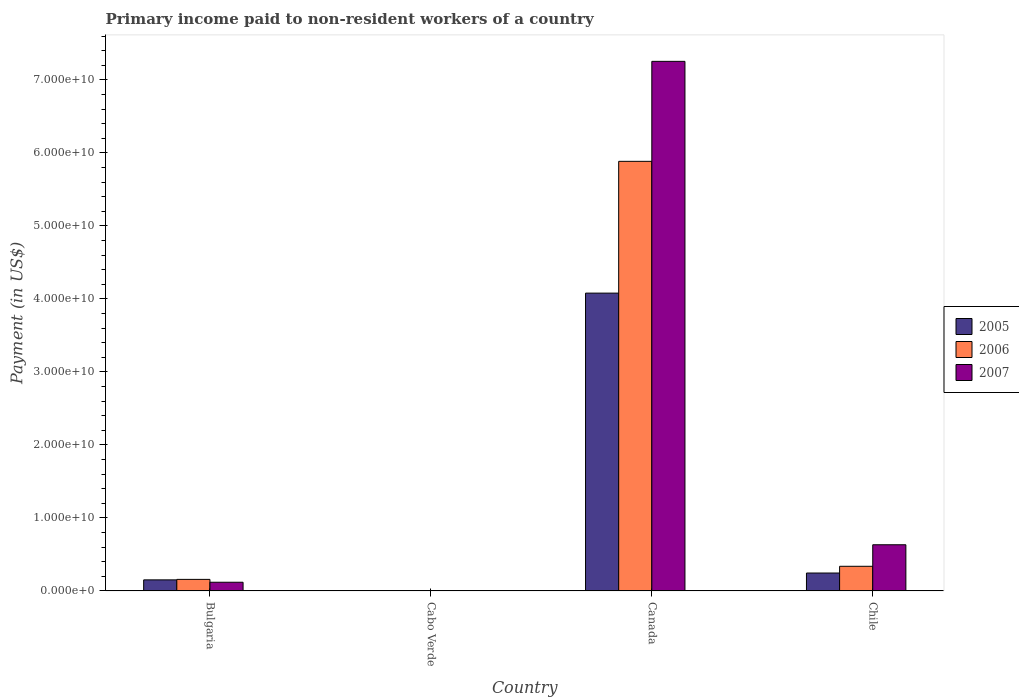How many different coloured bars are there?
Your answer should be compact. 3. How many groups of bars are there?
Provide a short and direct response. 4. Are the number of bars per tick equal to the number of legend labels?
Give a very brief answer. Yes. Are the number of bars on each tick of the X-axis equal?
Offer a terse response. Yes. What is the label of the 3rd group of bars from the left?
Offer a very short reply. Canada. What is the amount paid to workers in 2006 in Canada?
Provide a short and direct response. 5.89e+1. Across all countries, what is the maximum amount paid to workers in 2006?
Provide a short and direct response. 5.89e+1. Across all countries, what is the minimum amount paid to workers in 2005?
Offer a very short reply. 1.92e+07. In which country was the amount paid to workers in 2007 maximum?
Your answer should be compact. Canada. In which country was the amount paid to workers in 2006 minimum?
Offer a terse response. Cabo Verde. What is the total amount paid to workers in 2007 in the graph?
Ensure brevity in your answer.  8.01e+1. What is the difference between the amount paid to workers in 2005 in Cabo Verde and that in Canada?
Offer a terse response. -4.08e+1. What is the difference between the amount paid to workers in 2005 in Cabo Verde and the amount paid to workers in 2006 in Bulgaria?
Your answer should be compact. -1.56e+09. What is the average amount paid to workers in 2006 per country?
Give a very brief answer. 1.60e+1. What is the difference between the amount paid to workers of/in 2007 and amount paid to workers of/in 2005 in Bulgaria?
Your answer should be compact. -3.26e+08. What is the ratio of the amount paid to workers in 2005 in Bulgaria to that in Cabo Verde?
Your response must be concise. 78.83. Is the difference between the amount paid to workers in 2007 in Cabo Verde and Chile greater than the difference between the amount paid to workers in 2005 in Cabo Verde and Chile?
Make the answer very short. No. What is the difference between the highest and the second highest amount paid to workers in 2006?
Offer a terse response. -5.55e+1. What is the difference between the highest and the lowest amount paid to workers in 2006?
Keep it short and to the point. 5.88e+1. What does the 3rd bar from the right in Canada represents?
Provide a short and direct response. 2005. How many countries are there in the graph?
Provide a short and direct response. 4. What is the difference between two consecutive major ticks on the Y-axis?
Your answer should be compact. 1.00e+1. Does the graph contain any zero values?
Your answer should be very brief. No. What is the title of the graph?
Provide a short and direct response. Primary income paid to non-resident workers of a country. What is the label or title of the X-axis?
Give a very brief answer. Country. What is the label or title of the Y-axis?
Provide a succinct answer. Payment (in US$). What is the Payment (in US$) of 2005 in Bulgaria?
Make the answer very short. 1.52e+09. What is the Payment (in US$) of 2006 in Bulgaria?
Provide a succinct answer. 1.58e+09. What is the Payment (in US$) of 2007 in Bulgaria?
Give a very brief answer. 1.19e+09. What is the Payment (in US$) in 2005 in Cabo Verde?
Provide a succinct answer. 1.92e+07. What is the Payment (in US$) in 2006 in Cabo Verde?
Offer a very short reply. 1.91e+07. What is the Payment (in US$) in 2007 in Cabo Verde?
Your answer should be compact. 2.67e+07. What is the Payment (in US$) in 2005 in Canada?
Offer a terse response. 4.08e+1. What is the Payment (in US$) in 2006 in Canada?
Make the answer very short. 5.89e+1. What is the Payment (in US$) of 2007 in Canada?
Provide a succinct answer. 7.26e+1. What is the Payment (in US$) in 2005 in Chile?
Offer a very short reply. 2.45e+09. What is the Payment (in US$) in 2006 in Chile?
Your answer should be compact. 3.37e+09. What is the Payment (in US$) in 2007 in Chile?
Make the answer very short. 6.32e+09. Across all countries, what is the maximum Payment (in US$) in 2005?
Make the answer very short. 4.08e+1. Across all countries, what is the maximum Payment (in US$) in 2006?
Your answer should be very brief. 5.89e+1. Across all countries, what is the maximum Payment (in US$) in 2007?
Offer a very short reply. 7.26e+1. Across all countries, what is the minimum Payment (in US$) in 2005?
Offer a very short reply. 1.92e+07. Across all countries, what is the minimum Payment (in US$) in 2006?
Offer a very short reply. 1.91e+07. Across all countries, what is the minimum Payment (in US$) in 2007?
Provide a succinct answer. 2.67e+07. What is the total Payment (in US$) in 2005 in the graph?
Ensure brevity in your answer.  4.48e+1. What is the total Payment (in US$) in 2006 in the graph?
Give a very brief answer. 6.38e+1. What is the total Payment (in US$) in 2007 in the graph?
Your answer should be very brief. 8.01e+1. What is the difference between the Payment (in US$) in 2005 in Bulgaria and that in Cabo Verde?
Ensure brevity in your answer.  1.50e+09. What is the difference between the Payment (in US$) in 2006 in Bulgaria and that in Cabo Verde?
Offer a terse response. 1.56e+09. What is the difference between the Payment (in US$) in 2007 in Bulgaria and that in Cabo Verde?
Make the answer very short. 1.16e+09. What is the difference between the Payment (in US$) of 2005 in Bulgaria and that in Canada?
Keep it short and to the point. -3.93e+1. What is the difference between the Payment (in US$) in 2006 in Bulgaria and that in Canada?
Your answer should be very brief. -5.73e+1. What is the difference between the Payment (in US$) in 2007 in Bulgaria and that in Canada?
Give a very brief answer. -7.14e+1. What is the difference between the Payment (in US$) in 2005 in Bulgaria and that in Chile?
Keep it short and to the point. -9.36e+08. What is the difference between the Payment (in US$) of 2006 in Bulgaria and that in Chile?
Give a very brief answer. -1.79e+09. What is the difference between the Payment (in US$) in 2007 in Bulgaria and that in Chile?
Keep it short and to the point. -5.14e+09. What is the difference between the Payment (in US$) of 2005 in Cabo Verde and that in Canada?
Provide a succinct answer. -4.08e+1. What is the difference between the Payment (in US$) in 2006 in Cabo Verde and that in Canada?
Keep it short and to the point. -5.88e+1. What is the difference between the Payment (in US$) in 2007 in Cabo Verde and that in Canada?
Offer a very short reply. -7.25e+1. What is the difference between the Payment (in US$) in 2005 in Cabo Verde and that in Chile?
Make the answer very short. -2.43e+09. What is the difference between the Payment (in US$) in 2006 in Cabo Verde and that in Chile?
Offer a very short reply. -3.36e+09. What is the difference between the Payment (in US$) in 2007 in Cabo Verde and that in Chile?
Provide a succinct answer. -6.30e+09. What is the difference between the Payment (in US$) of 2005 in Canada and that in Chile?
Provide a succinct answer. 3.83e+1. What is the difference between the Payment (in US$) in 2006 in Canada and that in Chile?
Provide a succinct answer. 5.55e+1. What is the difference between the Payment (in US$) in 2007 in Canada and that in Chile?
Your response must be concise. 6.62e+1. What is the difference between the Payment (in US$) of 2005 in Bulgaria and the Payment (in US$) of 2006 in Cabo Verde?
Offer a terse response. 1.50e+09. What is the difference between the Payment (in US$) of 2005 in Bulgaria and the Payment (in US$) of 2007 in Cabo Verde?
Offer a very short reply. 1.49e+09. What is the difference between the Payment (in US$) in 2006 in Bulgaria and the Payment (in US$) in 2007 in Cabo Verde?
Offer a terse response. 1.55e+09. What is the difference between the Payment (in US$) in 2005 in Bulgaria and the Payment (in US$) in 2006 in Canada?
Ensure brevity in your answer.  -5.73e+1. What is the difference between the Payment (in US$) of 2005 in Bulgaria and the Payment (in US$) of 2007 in Canada?
Ensure brevity in your answer.  -7.10e+1. What is the difference between the Payment (in US$) of 2006 in Bulgaria and the Payment (in US$) of 2007 in Canada?
Ensure brevity in your answer.  -7.10e+1. What is the difference between the Payment (in US$) in 2005 in Bulgaria and the Payment (in US$) in 2006 in Chile?
Your answer should be compact. -1.86e+09. What is the difference between the Payment (in US$) of 2005 in Bulgaria and the Payment (in US$) of 2007 in Chile?
Your answer should be very brief. -4.81e+09. What is the difference between the Payment (in US$) of 2006 in Bulgaria and the Payment (in US$) of 2007 in Chile?
Ensure brevity in your answer.  -4.74e+09. What is the difference between the Payment (in US$) in 2005 in Cabo Verde and the Payment (in US$) in 2006 in Canada?
Keep it short and to the point. -5.88e+1. What is the difference between the Payment (in US$) in 2005 in Cabo Verde and the Payment (in US$) in 2007 in Canada?
Offer a terse response. -7.25e+1. What is the difference between the Payment (in US$) of 2006 in Cabo Verde and the Payment (in US$) of 2007 in Canada?
Your answer should be very brief. -7.25e+1. What is the difference between the Payment (in US$) of 2005 in Cabo Verde and the Payment (in US$) of 2006 in Chile?
Provide a succinct answer. -3.36e+09. What is the difference between the Payment (in US$) in 2005 in Cabo Verde and the Payment (in US$) in 2007 in Chile?
Provide a succinct answer. -6.31e+09. What is the difference between the Payment (in US$) in 2006 in Cabo Verde and the Payment (in US$) in 2007 in Chile?
Your answer should be compact. -6.31e+09. What is the difference between the Payment (in US$) of 2005 in Canada and the Payment (in US$) of 2006 in Chile?
Offer a terse response. 3.74e+1. What is the difference between the Payment (in US$) in 2005 in Canada and the Payment (in US$) in 2007 in Chile?
Ensure brevity in your answer.  3.45e+1. What is the difference between the Payment (in US$) of 2006 in Canada and the Payment (in US$) of 2007 in Chile?
Your response must be concise. 5.25e+1. What is the average Payment (in US$) in 2005 per country?
Make the answer very short. 1.12e+1. What is the average Payment (in US$) in 2006 per country?
Provide a short and direct response. 1.60e+1. What is the average Payment (in US$) in 2007 per country?
Your response must be concise. 2.00e+1. What is the difference between the Payment (in US$) of 2005 and Payment (in US$) of 2006 in Bulgaria?
Your response must be concise. -6.60e+07. What is the difference between the Payment (in US$) in 2005 and Payment (in US$) in 2007 in Bulgaria?
Offer a very short reply. 3.26e+08. What is the difference between the Payment (in US$) in 2006 and Payment (in US$) in 2007 in Bulgaria?
Provide a succinct answer. 3.92e+08. What is the difference between the Payment (in US$) of 2005 and Payment (in US$) of 2006 in Cabo Verde?
Give a very brief answer. 1.54e+05. What is the difference between the Payment (in US$) in 2005 and Payment (in US$) in 2007 in Cabo Verde?
Give a very brief answer. -7.50e+06. What is the difference between the Payment (in US$) of 2006 and Payment (in US$) of 2007 in Cabo Verde?
Ensure brevity in your answer.  -7.66e+06. What is the difference between the Payment (in US$) in 2005 and Payment (in US$) in 2006 in Canada?
Offer a terse response. -1.81e+1. What is the difference between the Payment (in US$) of 2005 and Payment (in US$) of 2007 in Canada?
Your answer should be very brief. -3.18e+1. What is the difference between the Payment (in US$) in 2006 and Payment (in US$) in 2007 in Canada?
Your answer should be very brief. -1.37e+1. What is the difference between the Payment (in US$) of 2005 and Payment (in US$) of 2006 in Chile?
Offer a terse response. -9.22e+08. What is the difference between the Payment (in US$) in 2005 and Payment (in US$) in 2007 in Chile?
Offer a terse response. -3.87e+09. What is the difference between the Payment (in US$) of 2006 and Payment (in US$) of 2007 in Chile?
Offer a very short reply. -2.95e+09. What is the ratio of the Payment (in US$) of 2005 in Bulgaria to that in Cabo Verde?
Your answer should be very brief. 78.83. What is the ratio of the Payment (in US$) in 2006 in Bulgaria to that in Cabo Verde?
Your response must be concise. 82.93. What is the ratio of the Payment (in US$) in 2007 in Bulgaria to that in Cabo Verde?
Offer a terse response. 44.5. What is the ratio of the Payment (in US$) in 2005 in Bulgaria to that in Canada?
Ensure brevity in your answer.  0.04. What is the ratio of the Payment (in US$) in 2006 in Bulgaria to that in Canada?
Offer a very short reply. 0.03. What is the ratio of the Payment (in US$) of 2007 in Bulgaria to that in Canada?
Your answer should be very brief. 0.02. What is the ratio of the Payment (in US$) of 2005 in Bulgaria to that in Chile?
Your answer should be compact. 0.62. What is the ratio of the Payment (in US$) of 2006 in Bulgaria to that in Chile?
Ensure brevity in your answer.  0.47. What is the ratio of the Payment (in US$) of 2007 in Bulgaria to that in Chile?
Your response must be concise. 0.19. What is the ratio of the Payment (in US$) in 2005 in Cabo Verde to that in Canada?
Your answer should be compact. 0. What is the ratio of the Payment (in US$) in 2006 in Cabo Verde to that in Canada?
Keep it short and to the point. 0. What is the ratio of the Payment (in US$) in 2007 in Cabo Verde to that in Canada?
Offer a terse response. 0. What is the ratio of the Payment (in US$) in 2005 in Cabo Verde to that in Chile?
Give a very brief answer. 0.01. What is the ratio of the Payment (in US$) in 2006 in Cabo Verde to that in Chile?
Provide a succinct answer. 0.01. What is the ratio of the Payment (in US$) in 2007 in Cabo Verde to that in Chile?
Make the answer very short. 0. What is the ratio of the Payment (in US$) of 2005 in Canada to that in Chile?
Make the answer very short. 16.64. What is the ratio of the Payment (in US$) of 2006 in Canada to that in Chile?
Provide a succinct answer. 17.44. What is the ratio of the Payment (in US$) in 2007 in Canada to that in Chile?
Keep it short and to the point. 11.47. What is the difference between the highest and the second highest Payment (in US$) of 2005?
Make the answer very short. 3.83e+1. What is the difference between the highest and the second highest Payment (in US$) of 2006?
Offer a terse response. 5.55e+1. What is the difference between the highest and the second highest Payment (in US$) of 2007?
Make the answer very short. 6.62e+1. What is the difference between the highest and the lowest Payment (in US$) in 2005?
Provide a succinct answer. 4.08e+1. What is the difference between the highest and the lowest Payment (in US$) of 2006?
Your answer should be very brief. 5.88e+1. What is the difference between the highest and the lowest Payment (in US$) in 2007?
Keep it short and to the point. 7.25e+1. 